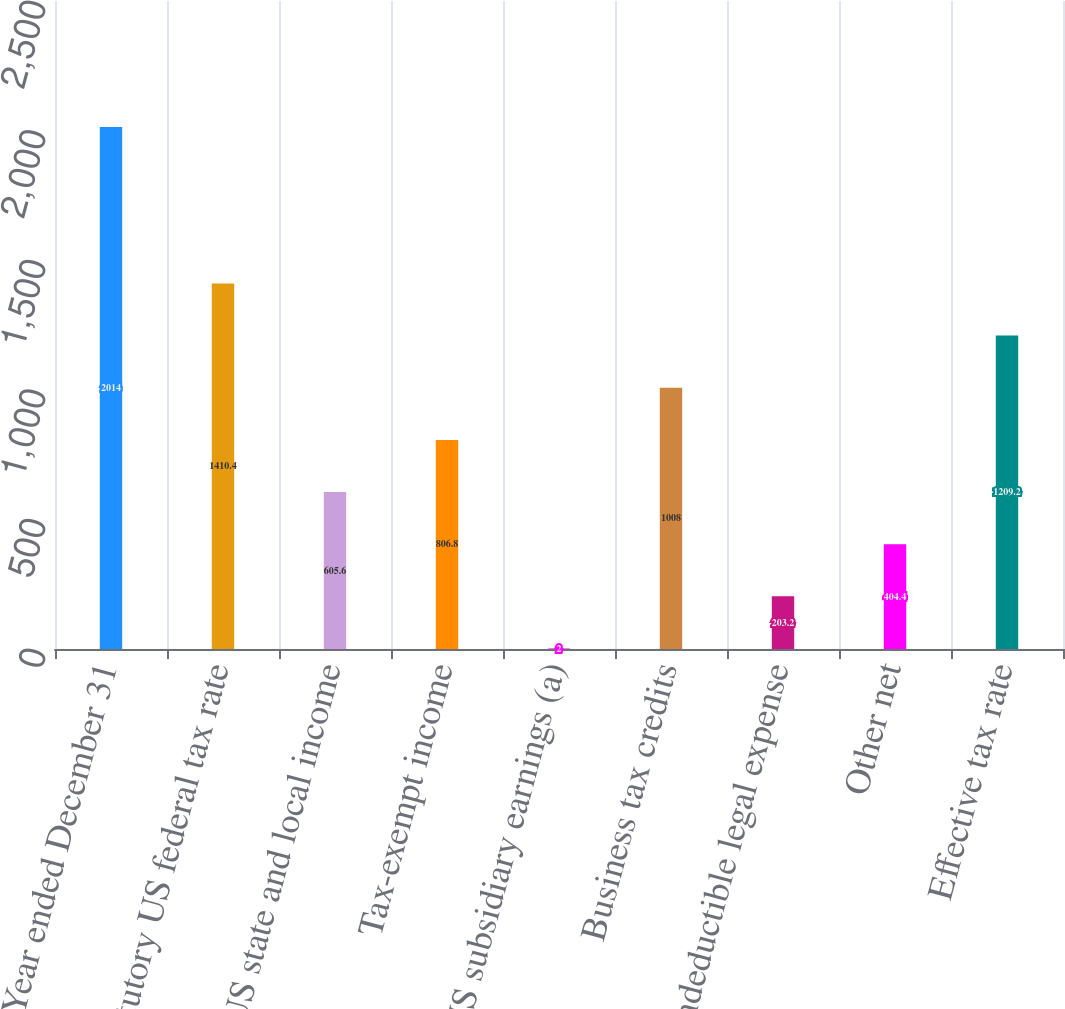Convert chart to OTSL. <chart><loc_0><loc_0><loc_500><loc_500><bar_chart><fcel>Year ended December 31<fcel>Statutory US federal tax rate<fcel>US state and local income<fcel>Tax-exempt income<fcel>Non-US subsidiary earnings (a)<fcel>Business tax credits<fcel>Nondeductible legal expense<fcel>Other net<fcel>Effective tax rate<nl><fcel>2014<fcel>1410.4<fcel>605.6<fcel>806.8<fcel>2<fcel>1008<fcel>203.2<fcel>404.4<fcel>1209.2<nl></chart> 